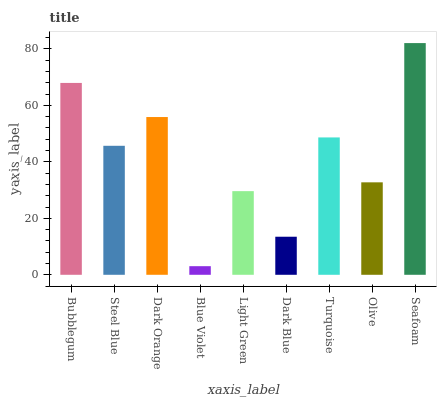Is Blue Violet the minimum?
Answer yes or no. Yes. Is Seafoam the maximum?
Answer yes or no. Yes. Is Steel Blue the minimum?
Answer yes or no. No. Is Steel Blue the maximum?
Answer yes or no. No. Is Bubblegum greater than Steel Blue?
Answer yes or no. Yes. Is Steel Blue less than Bubblegum?
Answer yes or no. Yes. Is Steel Blue greater than Bubblegum?
Answer yes or no. No. Is Bubblegum less than Steel Blue?
Answer yes or no. No. Is Steel Blue the high median?
Answer yes or no. Yes. Is Steel Blue the low median?
Answer yes or no. Yes. Is Dark Orange the high median?
Answer yes or no. No. Is Bubblegum the low median?
Answer yes or no. No. 